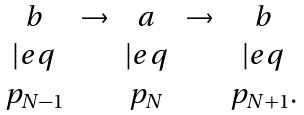<formula> <loc_0><loc_0><loc_500><loc_500>\begin{matrix} b & \rightarrow & a & \rightarrow & b \\ | e q & & | e q & & | e q \\ p _ { N - 1 } & & p _ { N } & & p _ { N + 1 } . \end{matrix}</formula> 